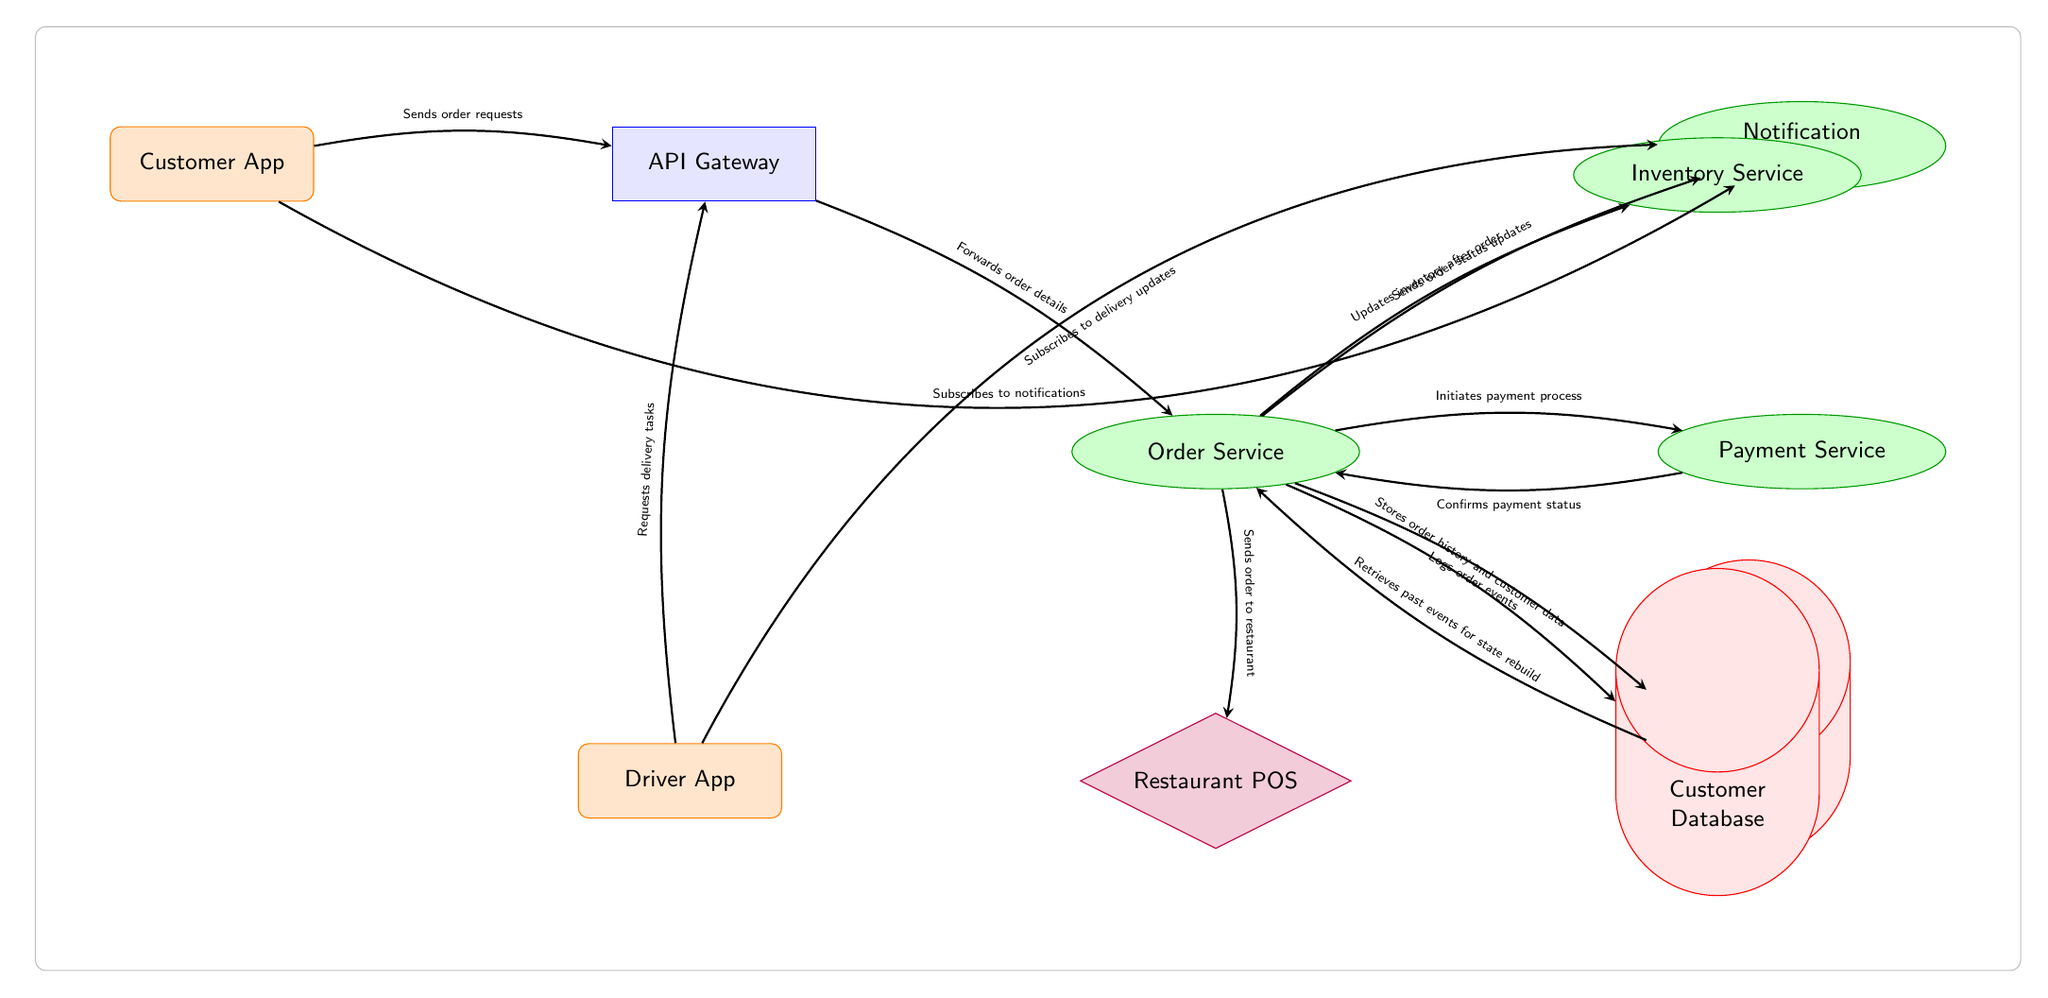What is the entry point for the customer interaction? The diagram shows the "Customer App" as the entry point where customers send their order requests before reaching other components.
Answer: Customer App How many microservices are present in the diagram? By inspecting the diagram, we see that there are four distinct microservices: Order Service, Payment Service, Notification Service, and Inventory Service.
Answer: Four What does the API Gateway do with order requests? The diagram indicates that the API Gateway forwards order details from the Customer App to the Order Service for processing.
Answer: Forwards order details Which service is responsible for logging order events? The arrow from the Order Service to the Event Store suggests that the Order Service logs order events to the Event Store.
Answer: Event Store What information do delivery drivers subscribe to? The diagram illustrates that the Driver App subscribes to delivery updates via the Notification Service, which means it receives notifications about delivery statuses.
Answer: Delivery updates Which service updates the inventory after an order is placed? The diagram clearly shows that the Order Service sends a request to the Inventory Service to update inventory after order confirmation.
Answer: Inventory Service How does the Customer App receive notifications? The diagram depicts that the Customer App subscribes to notifications through the Notification Service, allowing it to receive updates based on orders and status changes.
Answer: Subscribes to notifications What kind of database is represented in the diagram? The diagram indicates that the Event Store is a cylindrical database, specifically denoted to log events and retrieve past events for state rebuild.
Answer: Event Store What process is initiated after the Order Service sends an order to the Restaurant POS? The diagram shows that after sending the order to the Restaurant POS, the Order Service initiates the payment process with the Payment Service.
Answer: Initiates payment process How does the Order Service affect customer data storage? The diagram indicates that the Order Service stores order history and customer data in the Customer Database, linking order processing with data storage.
Answer: Customer Database 